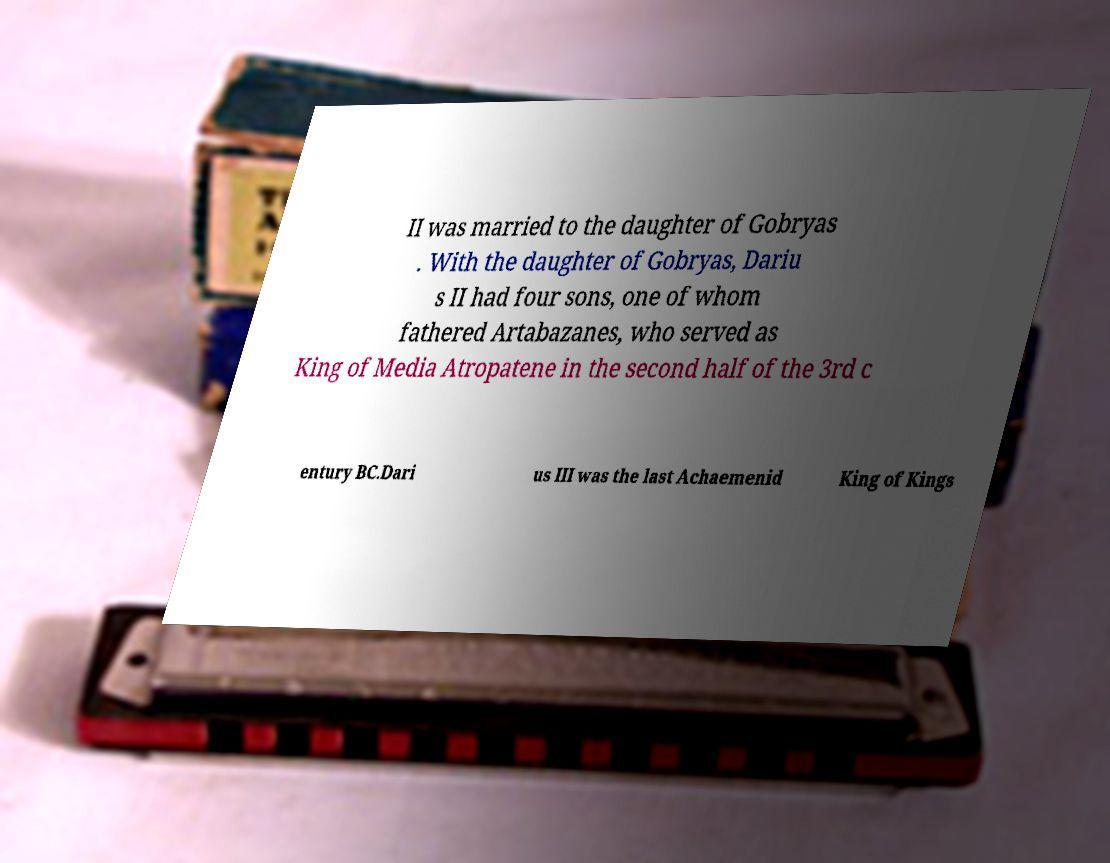Please identify and transcribe the text found in this image. II was married to the daughter of Gobryas . With the daughter of Gobryas, Dariu s II had four sons, one of whom fathered Artabazanes, who served as King of Media Atropatene in the second half of the 3rd c entury BC.Dari us III was the last Achaemenid King of Kings 